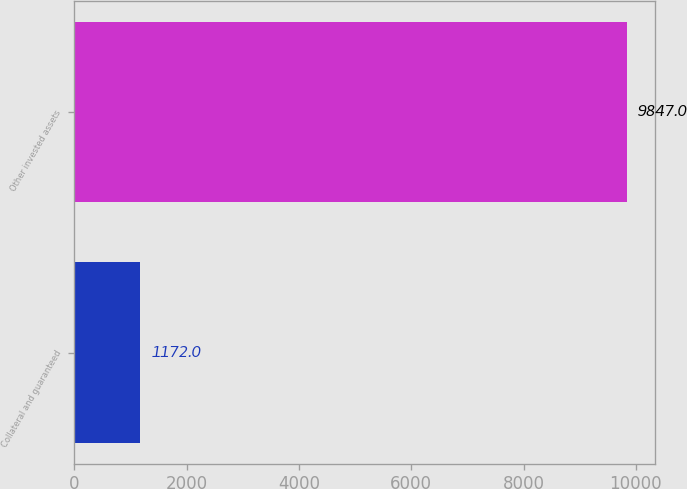Convert chart to OTSL. <chart><loc_0><loc_0><loc_500><loc_500><bar_chart><fcel>Collateral and guaranteed<fcel>Other invested assets<nl><fcel>1172<fcel>9847<nl></chart> 